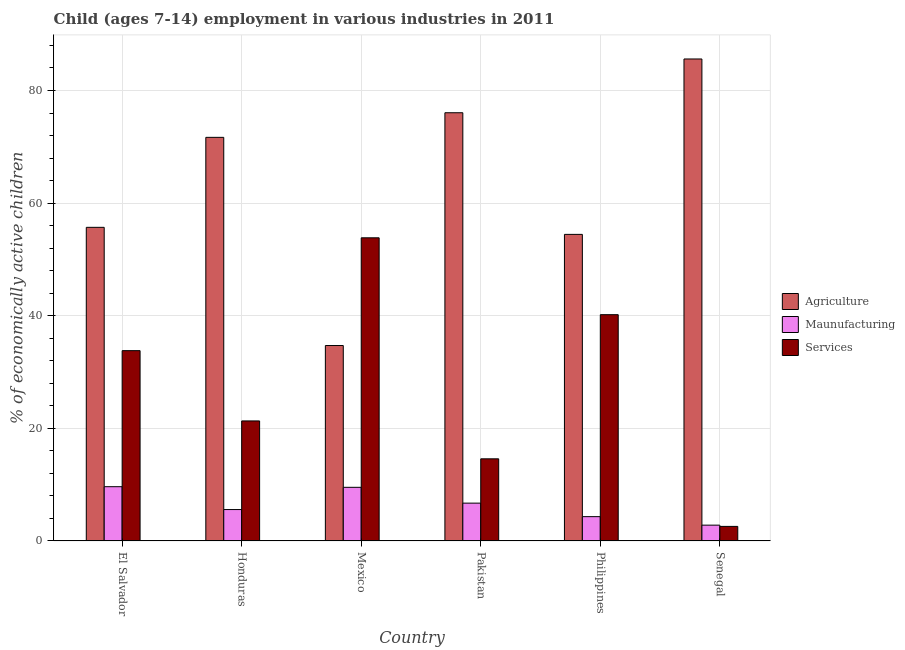Are the number of bars on each tick of the X-axis equal?
Give a very brief answer. Yes. How many bars are there on the 2nd tick from the left?
Offer a very short reply. 3. How many bars are there on the 2nd tick from the right?
Offer a terse response. 3. In how many cases, is the number of bars for a given country not equal to the number of legend labels?
Ensure brevity in your answer.  0. What is the percentage of economically active children in manufacturing in Mexico?
Offer a terse response. 9.53. Across all countries, what is the maximum percentage of economically active children in services?
Keep it short and to the point. 53.84. Across all countries, what is the minimum percentage of economically active children in agriculture?
Offer a terse response. 34.71. In which country was the percentage of economically active children in manufacturing maximum?
Ensure brevity in your answer.  El Salvador. What is the total percentage of economically active children in services in the graph?
Your response must be concise. 166.33. What is the difference between the percentage of economically active children in agriculture in El Salvador and that in Senegal?
Offer a terse response. -29.9. What is the difference between the percentage of economically active children in services in Honduras and the percentage of economically active children in agriculture in Pakistan?
Provide a short and direct response. -54.73. What is the average percentage of economically active children in agriculture per country?
Make the answer very short. 63.03. What is the difference between the percentage of economically active children in agriculture and percentage of economically active children in manufacturing in Philippines?
Provide a succinct answer. 50.13. What is the ratio of the percentage of economically active children in agriculture in El Salvador to that in Senegal?
Your response must be concise. 0.65. Is the percentage of economically active children in agriculture in Honduras less than that in Senegal?
Give a very brief answer. Yes. Is the difference between the percentage of economically active children in manufacturing in El Salvador and Mexico greater than the difference between the percentage of economically active children in services in El Salvador and Mexico?
Provide a succinct answer. Yes. What is the difference between the highest and the second highest percentage of economically active children in services?
Your answer should be compact. 13.65. What is the difference between the highest and the lowest percentage of economically active children in manufacturing?
Offer a terse response. 6.83. In how many countries, is the percentage of economically active children in manufacturing greater than the average percentage of economically active children in manufacturing taken over all countries?
Your answer should be compact. 3. What does the 3rd bar from the left in Mexico represents?
Offer a terse response. Services. What does the 3rd bar from the right in Philippines represents?
Give a very brief answer. Agriculture. Are all the bars in the graph horizontal?
Your answer should be compact. No. Are the values on the major ticks of Y-axis written in scientific E-notation?
Ensure brevity in your answer.  No. Does the graph contain grids?
Provide a short and direct response. Yes. Where does the legend appear in the graph?
Your response must be concise. Center right. How many legend labels are there?
Give a very brief answer. 3. How are the legend labels stacked?
Your answer should be very brief. Vertical. What is the title of the graph?
Offer a very short reply. Child (ages 7-14) employment in various industries in 2011. What is the label or title of the X-axis?
Give a very brief answer. Country. What is the label or title of the Y-axis?
Ensure brevity in your answer.  % of economically active children. What is the % of economically active children of Agriculture in El Salvador?
Ensure brevity in your answer.  55.7. What is the % of economically active children in Maunufacturing in El Salvador?
Give a very brief answer. 9.64. What is the % of economically active children in Services in El Salvador?
Make the answer very short. 33.8. What is the % of economically active children in Agriculture in Honduras?
Offer a terse response. 71.68. What is the % of economically active children in Maunufacturing in Honduras?
Offer a very short reply. 5.58. What is the % of economically active children of Services in Honduras?
Provide a short and direct response. 21.32. What is the % of economically active children of Agriculture in Mexico?
Provide a succinct answer. 34.71. What is the % of economically active children of Maunufacturing in Mexico?
Keep it short and to the point. 9.53. What is the % of economically active children of Services in Mexico?
Provide a succinct answer. 53.84. What is the % of economically active children of Agriculture in Pakistan?
Provide a succinct answer. 76.05. What is the % of economically active children in Maunufacturing in Pakistan?
Ensure brevity in your answer.  6.72. What is the % of economically active children of Services in Pakistan?
Your answer should be compact. 14.59. What is the % of economically active children in Agriculture in Philippines?
Give a very brief answer. 54.45. What is the % of economically active children of Maunufacturing in Philippines?
Your answer should be very brief. 4.32. What is the % of economically active children in Services in Philippines?
Offer a terse response. 40.19. What is the % of economically active children of Agriculture in Senegal?
Provide a short and direct response. 85.6. What is the % of economically active children of Maunufacturing in Senegal?
Offer a very short reply. 2.81. What is the % of economically active children of Services in Senegal?
Offer a very short reply. 2.59. Across all countries, what is the maximum % of economically active children in Agriculture?
Your answer should be compact. 85.6. Across all countries, what is the maximum % of economically active children of Maunufacturing?
Provide a short and direct response. 9.64. Across all countries, what is the maximum % of economically active children in Services?
Provide a succinct answer. 53.84. Across all countries, what is the minimum % of economically active children of Agriculture?
Ensure brevity in your answer.  34.71. Across all countries, what is the minimum % of economically active children of Maunufacturing?
Your answer should be compact. 2.81. Across all countries, what is the minimum % of economically active children in Services?
Your answer should be very brief. 2.59. What is the total % of economically active children of Agriculture in the graph?
Ensure brevity in your answer.  378.19. What is the total % of economically active children in Maunufacturing in the graph?
Ensure brevity in your answer.  38.6. What is the total % of economically active children in Services in the graph?
Give a very brief answer. 166.33. What is the difference between the % of economically active children of Agriculture in El Salvador and that in Honduras?
Give a very brief answer. -15.98. What is the difference between the % of economically active children of Maunufacturing in El Salvador and that in Honduras?
Provide a short and direct response. 4.06. What is the difference between the % of economically active children of Services in El Salvador and that in Honduras?
Ensure brevity in your answer.  12.48. What is the difference between the % of economically active children in Agriculture in El Salvador and that in Mexico?
Offer a terse response. 20.99. What is the difference between the % of economically active children of Maunufacturing in El Salvador and that in Mexico?
Offer a terse response. 0.11. What is the difference between the % of economically active children of Services in El Salvador and that in Mexico?
Give a very brief answer. -20.04. What is the difference between the % of economically active children in Agriculture in El Salvador and that in Pakistan?
Offer a terse response. -20.35. What is the difference between the % of economically active children in Maunufacturing in El Salvador and that in Pakistan?
Your answer should be compact. 2.92. What is the difference between the % of economically active children in Services in El Salvador and that in Pakistan?
Your answer should be compact. 19.21. What is the difference between the % of economically active children of Agriculture in El Salvador and that in Philippines?
Your answer should be compact. 1.25. What is the difference between the % of economically active children in Maunufacturing in El Salvador and that in Philippines?
Provide a short and direct response. 5.32. What is the difference between the % of economically active children in Services in El Salvador and that in Philippines?
Provide a succinct answer. -6.39. What is the difference between the % of economically active children of Agriculture in El Salvador and that in Senegal?
Give a very brief answer. -29.9. What is the difference between the % of economically active children in Maunufacturing in El Salvador and that in Senegal?
Provide a succinct answer. 6.83. What is the difference between the % of economically active children in Services in El Salvador and that in Senegal?
Provide a succinct answer. 31.21. What is the difference between the % of economically active children in Agriculture in Honduras and that in Mexico?
Ensure brevity in your answer.  36.97. What is the difference between the % of economically active children in Maunufacturing in Honduras and that in Mexico?
Give a very brief answer. -3.95. What is the difference between the % of economically active children in Services in Honduras and that in Mexico?
Ensure brevity in your answer.  -32.52. What is the difference between the % of economically active children of Agriculture in Honduras and that in Pakistan?
Your answer should be compact. -4.37. What is the difference between the % of economically active children of Maunufacturing in Honduras and that in Pakistan?
Give a very brief answer. -1.14. What is the difference between the % of economically active children of Services in Honduras and that in Pakistan?
Give a very brief answer. 6.73. What is the difference between the % of economically active children of Agriculture in Honduras and that in Philippines?
Offer a very short reply. 17.23. What is the difference between the % of economically active children in Maunufacturing in Honduras and that in Philippines?
Keep it short and to the point. 1.26. What is the difference between the % of economically active children of Services in Honduras and that in Philippines?
Your answer should be compact. -18.87. What is the difference between the % of economically active children of Agriculture in Honduras and that in Senegal?
Provide a succinct answer. -13.92. What is the difference between the % of economically active children of Maunufacturing in Honduras and that in Senegal?
Provide a succinct answer. 2.77. What is the difference between the % of economically active children of Services in Honduras and that in Senegal?
Offer a terse response. 18.73. What is the difference between the % of economically active children of Agriculture in Mexico and that in Pakistan?
Your response must be concise. -41.34. What is the difference between the % of economically active children of Maunufacturing in Mexico and that in Pakistan?
Your response must be concise. 2.81. What is the difference between the % of economically active children of Services in Mexico and that in Pakistan?
Ensure brevity in your answer.  39.25. What is the difference between the % of economically active children of Agriculture in Mexico and that in Philippines?
Keep it short and to the point. -19.74. What is the difference between the % of economically active children in Maunufacturing in Mexico and that in Philippines?
Give a very brief answer. 5.21. What is the difference between the % of economically active children of Services in Mexico and that in Philippines?
Ensure brevity in your answer.  13.65. What is the difference between the % of economically active children of Agriculture in Mexico and that in Senegal?
Ensure brevity in your answer.  -50.89. What is the difference between the % of economically active children of Maunufacturing in Mexico and that in Senegal?
Your answer should be compact. 6.72. What is the difference between the % of economically active children in Services in Mexico and that in Senegal?
Your answer should be very brief. 51.25. What is the difference between the % of economically active children of Agriculture in Pakistan and that in Philippines?
Provide a succinct answer. 21.6. What is the difference between the % of economically active children in Maunufacturing in Pakistan and that in Philippines?
Provide a succinct answer. 2.4. What is the difference between the % of economically active children of Services in Pakistan and that in Philippines?
Make the answer very short. -25.6. What is the difference between the % of economically active children in Agriculture in Pakistan and that in Senegal?
Make the answer very short. -9.55. What is the difference between the % of economically active children of Maunufacturing in Pakistan and that in Senegal?
Provide a succinct answer. 3.91. What is the difference between the % of economically active children of Agriculture in Philippines and that in Senegal?
Offer a terse response. -31.15. What is the difference between the % of economically active children of Maunufacturing in Philippines and that in Senegal?
Offer a very short reply. 1.51. What is the difference between the % of economically active children of Services in Philippines and that in Senegal?
Give a very brief answer. 37.6. What is the difference between the % of economically active children of Agriculture in El Salvador and the % of economically active children of Maunufacturing in Honduras?
Ensure brevity in your answer.  50.12. What is the difference between the % of economically active children of Agriculture in El Salvador and the % of economically active children of Services in Honduras?
Make the answer very short. 34.38. What is the difference between the % of economically active children in Maunufacturing in El Salvador and the % of economically active children in Services in Honduras?
Provide a short and direct response. -11.68. What is the difference between the % of economically active children in Agriculture in El Salvador and the % of economically active children in Maunufacturing in Mexico?
Your answer should be very brief. 46.17. What is the difference between the % of economically active children in Agriculture in El Salvador and the % of economically active children in Services in Mexico?
Offer a terse response. 1.86. What is the difference between the % of economically active children of Maunufacturing in El Salvador and the % of economically active children of Services in Mexico?
Your response must be concise. -44.2. What is the difference between the % of economically active children in Agriculture in El Salvador and the % of economically active children in Maunufacturing in Pakistan?
Provide a succinct answer. 48.98. What is the difference between the % of economically active children of Agriculture in El Salvador and the % of economically active children of Services in Pakistan?
Make the answer very short. 41.11. What is the difference between the % of economically active children in Maunufacturing in El Salvador and the % of economically active children in Services in Pakistan?
Your answer should be very brief. -4.95. What is the difference between the % of economically active children of Agriculture in El Salvador and the % of economically active children of Maunufacturing in Philippines?
Make the answer very short. 51.38. What is the difference between the % of economically active children in Agriculture in El Salvador and the % of economically active children in Services in Philippines?
Give a very brief answer. 15.51. What is the difference between the % of economically active children in Maunufacturing in El Salvador and the % of economically active children in Services in Philippines?
Provide a short and direct response. -30.55. What is the difference between the % of economically active children of Agriculture in El Salvador and the % of economically active children of Maunufacturing in Senegal?
Keep it short and to the point. 52.89. What is the difference between the % of economically active children of Agriculture in El Salvador and the % of economically active children of Services in Senegal?
Give a very brief answer. 53.11. What is the difference between the % of economically active children in Maunufacturing in El Salvador and the % of economically active children in Services in Senegal?
Make the answer very short. 7.05. What is the difference between the % of economically active children in Agriculture in Honduras and the % of economically active children in Maunufacturing in Mexico?
Give a very brief answer. 62.15. What is the difference between the % of economically active children in Agriculture in Honduras and the % of economically active children in Services in Mexico?
Provide a succinct answer. 17.84. What is the difference between the % of economically active children of Maunufacturing in Honduras and the % of economically active children of Services in Mexico?
Make the answer very short. -48.26. What is the difference between the % of economically active children of Agriculture in Honduras and the % of economically active children of Maunufacturing in Pakistan?
Ensure brevity in your answer.  64.96. What is the difference between the % of economically active children in Agriculture in Honduras and the % of economically active children in Services in Pakistan?
Make the answer very short. 57.09. What is the difference between the % of economically active children in Maunufacturing in Honduras and the % of economically active children in Services in Pakistan?
Provide a short and direct response. -9.01. What is the difference between the % of economically active children in Agriculture in Honduras and the % of economically active children in Maunufacturing in Philippines?
Your answer should be very brief. 67.36. What is the difference between the % of economically active children in Agriculture in Honduras and the % of economically active children in Services in Philippines?
Provide a succinct answer. 31.49. What is the difference between the % of economically active children in Maunufacturing in Honduras and the % of economically active children in Services in Philippines?
Make the answer very short. -34.61. What is the difference between the % of economically active children in Agriculture in Honduras and the % of economically active children in Maunufacturing in Senegal?
Offer a terse response. 68.87. What is the difference between the % of economically active children in Agriculture in Honduras and the % of economically active children in Services in Senegal?
Give a very brief answer. 69.09. What is the difference between the % of economically active children in Maunufacturing in Honduras and the % of economically active children in Services in Senegal?
Your response must be concise. 2.99. What is the difference between the % of economically active children in Agriculture in Mexico and the % of economically active children in Maunufacturing in Pakistan?
Your answer should be very brief. 27.99. What is the difference between the % of economically active children in Agriculture in Mexico and the % of economically active children in Services in Pakistan?
Offer a very short reply. 20.12. What is the difference between the % of economically active children of Maunufacturing in Mexico and the % of economically active children of Services in Pakistan?
Provide a short and direct response. -5.06. What is the difference between the % of economically active children in Agriculture in Mexico and the % of economically active children in Maunufacturing in Philippines?
Make the answer very short. 30.39. What is the difference between the % of economically active children of Agriculture in Mexico and the % of economically active children of Services in Philippines?
Provide a short and direct response. -5.48. What is the difference between the % of economically active children of Maunufacturing in Mexico and the % of economically active children of Services in Philippines?
Offer a very short reply. -30.66. What is the difference between the % of economically active children of Agriculture in Mexico and the % of economically active children of Maunufacturing in Senegal?
Give a very brief answer. 31.9. What is the difference between the % of economically active children of Agriculture in Mexico and the % of economically active children of Services in Senegal?
Your answer should be compact. 32.12. What is the difference between the % of economically active children of Maunufacturing in Mexico and the % of economically active children of Services in Senegal?
Offer a very short reply. 6.94. What is the difference between the % of economically active children of Agriculture in Pakistan and the % of economically active children of Maunufacturing in Philippines?
Offer a very short reply. 71.73. What is the difference between the % of economically active children in Agriculture in Pakistan and the % of economically active children in Services in Philippines?
Provide a succinct answer. 35.86. What is the difference between the % of economically active children of Maunufacturing in Pakistan and the % of economically active children of Services in Philippines?
Provide a succinct answer. -33.47. What is the difference between the % of economically active children in Agriculture in Pakistan and the % of economically active children in Maunufacturing in Senegal?
Provide a succinct answer. 73.24. What is the difference between the % of economically active children of Agriculture in Pakistan and the % of economically active children of Services in Senegal?
Provide a short and direct response. 73.46. What is the difference between the % of economically active children in Maunufacturing in Pakistan and the % of economically active children in Services in Senegal?
Give a very brief answer. 4.13. What is the difference between the % of economically active children of Agriculture in Philippines and the % of economically active children of Maunufacturing in Senegal?
Offer a very short reply. 51.64. What is the difference between the % of economically active children of Agriculture in Philippines and the % of economically active children of Services in Senegal?
Offer a very short reply. 51.86. What is the difference between the % of economically active children in Maunufacturing in Philippines and the % of economically active children in Services in Senegal?
Offer a terse response. 1.73. What is the average % of economically active children in Agriculture per country?
Make the answer very short. 63.03. What is the average % of economically active children in Maunufacturing per country?
Your answer should be very brief. 6.43. What is the average % of economically active children of Services per country?
Your answer should be very brief. 27.72. What is the difference between the % of economically active children of Agriculture and % of economically active children of Maunufacturing in El Salvador?
Offer a very short reply. 46.06. What is the difference between the % of economically active children of Agriculture and % of economically active children of Services in El Salvador?
Your response must be concise. 21.9. What is the difference between the % of economically active children in Maunufacturing and % of economically active children in Services in El Salvador?
Keep it short and to the point. -24.16. What is the difference between the % of economically active children of Agriculture and % of economically active children of Maunufacturing in Honduras?
Your answer should be very brief. 66.1. What is the difference between the % of economically active children of Agriculture and % of economically active children of Services in Honduras?
Offer a very short reply. 50.36. What is the difference between the % of economically active children in Maunufacturing and % of economically active children in Services in Honduras?
Your answer should be compact. -15.74. What is the difference between the % of economically active children in Agriculture and % of economically active children in Maunufacturing in Mexico?
Your answer should be compact. 25.18. What is the difference between the % of economically active children in Agriculture and % of economically active children in Services in Mexico?
Your answer should be compact. -19.13. What is the difference between the % of economically active children of Maunufacturing and % of economically active children of Services in Mexico?
Make the answer very short. -44.31. What is the difference between the % of economically active children of Agriculture and % of economically active children of Maunufacturing in Pakistan?
Make the answer very short. 69.33. What is the difference between the % of economically active children in Agriculture and % of economically active children in Services in Pakistan?
Give a very brief answer. 61.46. What is the difference between the % of economically active children in Maunufacturing and % of economically active children in Services in Pakistan?
Your response must be concise. -7.87. What is the difference between the % of economically active children of Agriculture and % of economically active children of Maunufacturing in Philippines?
Ensure brevity in your answer.  50.13. What is the difference between the % of economically active children in Agriculture and % of economically active children in Services in Philippines?
Offer a terse response. 14.26. What is the difference between the % of economically active children of Maunufacturing and % of economically active children of Services in Philippines?
Your answer should be very brief. -35.87. What is the difference between the % of economically active children in Agriculture and % of economically active children in Maunufacturing in Senegal?
Your answer should be very brief. 82.79. What is the difference between the % of economically active children in Agriculture and % of economically active children in Services in Senegal?
Provide a succinct answer. 83.01. What is the difference between the % of economically active children of Maunufacturing and % of economically active children of Services in Senegal?
Offer a terse response. 0.22. What is the ratio of the % of economically active children in Agriculture in El Salvador to that in Honduras?
Ensure brevity in your answer.  0.78. What is the ratio of the % of economically active children of Maunufacturing in El Salvador to that in Honduras?
Provide a short and direct response. 1.73. What is the ratio of the % of economically active children of Services in El Salvador to that in Honduras?
Your answer should be compact. 1.59. What is the ratio of the % of economically active children in Agriculture in El Salvador to that in Mexico?
Your answer should be very brief. 1.6. What is the ratio of the % of economically active children of Maunufacturing in El Salvador to that in Mexico?
Your response must be concise. 1.01. What is the ratio of the % of economically active children in Services in El Salvador to that in Mexico?
Offer a terse response. 0.63. What is the ratio of the % of economically active children in Agriculture in El Salvador to that in Pakistan?
Keep it short and to the point. 0.73. What is the ratio of the % of economically active children of Maunufacturing in El Salvador to that in Pakistan?
Provide a succinct answer. 1.43. What is the ratio of the % of economically active children of Services in El Salvador to that in Pakistan?
Keep it short and to the point. 2.32. What is the ratio of the % of economically active children in Agriculture in El Salvador to that in Philippines?
Your answer should be very brief. 1.02. What is the ratio of the % of economically active children in Maunufacturing in El Salvador to that in Philippines?
Offer a terse response. 2.23. What is the ratio of the % of economically active children in Services in El Salvador to that in Philippines?
Offer a very short reply. 0.84. What is the ratio of the % of economically active children of Agriculture in El Salvador to that in Senegal?
Your answer should be compact. 0.65. What is the ratio of the % of economically active children of Maunufacturing in El Salvador to that in Senegal?
Provide a succinct answer. 3.43. What is the ratio of the % of economically active children of Services in El Salvador to that in Senegal?
Keep it short and to the point. 13.05. What is the ratio of the % of economically active children in Agriculture in Honduras to that in Mexico?
Your response must be concise. 2.07. What is the ratio of the % of economically active children of Maunufacturing in Honduras to that in Mexico?
Offer a very short reply. 0.59. What is the ratio of the % of economically active children in Services in Honduras to that in Mexico?
Give a very brief answer. 0.4. What is the ratio of the % of economically active children in Agriculture in Honduras to that in Pakistan?
Make the answer very short. 0.94. What is the ratio of the % of economically active children of Maunufacturing in Honduras to that in Pakistan?
Your answer should be compact. 0.83. What is the ratio of the % of economically active children in Services in Honduras to that in Pakistan?
Make the answer very short. 1.46. What is the ratio of the % of economically active children in Agriculture in Honduras to that in Philippines?
Your response must be concise. 1.32. What is the ratio of the % of economically active children of Maunufacturing in Honduras to that in Philippines?
Make the answer very short. 1.29. What is the ratio of the % of economically active children of Services in Honduras to that in Philippines?
Your answer should be compact. 0.53. What is the ratio of the % of economically active children of Agriculture in Honduras to that in Senegal?
Give a very brief answer. 0.84. What is the ratio of the % of economically active children in Maunufacturing in Honduras to that in Senegal?
Provide a succinct answer. 1.99. What is the ratio of the % of economically active children of Services in Honduras to that in Senegal?
Give a very brief answer. 8.23. What is the ratio of the % of economically active children in Agriculture in Mexico to that in Pakistan?
Provide a succinct answer. 0.46. What is the ratio of the % of economically active children in Maunufacturing in Mexico to that in Pakistan?
Provide a succinct answer. 1.42. What is the ratio of the % of economically active children of Services in Mexico to that in Pakistan?
Provide a succinct answer. 3.69. What is the ratio of the % of economically active children of Agriculture in Mexico to that in Philippines?
Your response must be concise. 0.64. What is the ratio of the % of economically active children of Maunufacturing in Mexico to that in Philippines?
Offer a terse response. 2.21. What is the ratio of the % of economically active children of Services in Mexico to that in Philippines?
Provide a succinct answer. 1.34. What is the ratio of the % of economically active children of Agriculture in Mexico to that in Senegal?
Ensure brevity in your answer.  0.41. What is the ratio of the % of economically active children in Maunufacturing in Mexico to that in Senegal?
Provide a succinct answer. 3.39. What is the ratio of the % of economically active children of Services in Mexico to that in Senegal?
Your answer should be very brief. 20.79. What is the ratio of the % of economically active children in Agriculture in Pakistan to that in Philippines?
Your answer should be very brief. 1.4. What is the ratio of the % of economically active children in Maunufacturing in Pakistan to that in Philippines?
Offer a very short reply. 1.56. What is the ratio of the % of economically active children of Services in Pakistan to that in Philippines?
Offer a very short reply. 0.36. What is the ratio of the % of economically active children of Agriculture in Pakistan to that in Senegal?
Provide a succinct answer. 0.89. What is the ratio of the % of economically active children in Maunufacturing in Pakistan to that in Senegal?
Provide a succinct answer. 2.39. What is the ratio of the % of economically active children in Services in Pakistan to that in Senegal?
Offer a very short reply. 5.63. What is the ratio of the % of economically active children in Agriculture in Philippines to that in Senegal?
Make the answer very short. 0.64. What is the ratio of the % of economically active children in Maunufacturing in Philippines to that in Senegal?
Ensure brevity in your answer.  1.54. What is the ratio of the % of economically active children of Services in Philippines to that in Senegal?
Ensure brevity in your answer.  15.52. What is the difference between the highest and the second highest % of economically active children in Agriculture?
Keep it short and to the point. 9.55. What is the difference between the highest and the second highest % of economically active children in Maunufacturing?
Offer a terse response. 0.11. What is the difference between the highest and the second highest % of economically active children in Services?
Give a very brief answer. 13.65. What is the difference between the highest and the lowest % of economically active children in Agriculture?
Give a very brief answer. 50.89. What is the difference between the highest and the lowest % of economically active children in Maunufacturing?
Offer a terse response. 6.83. What is the difference between the highest and the lowest % of economically active children of Services?
Your answer should be compact. 51.25. 